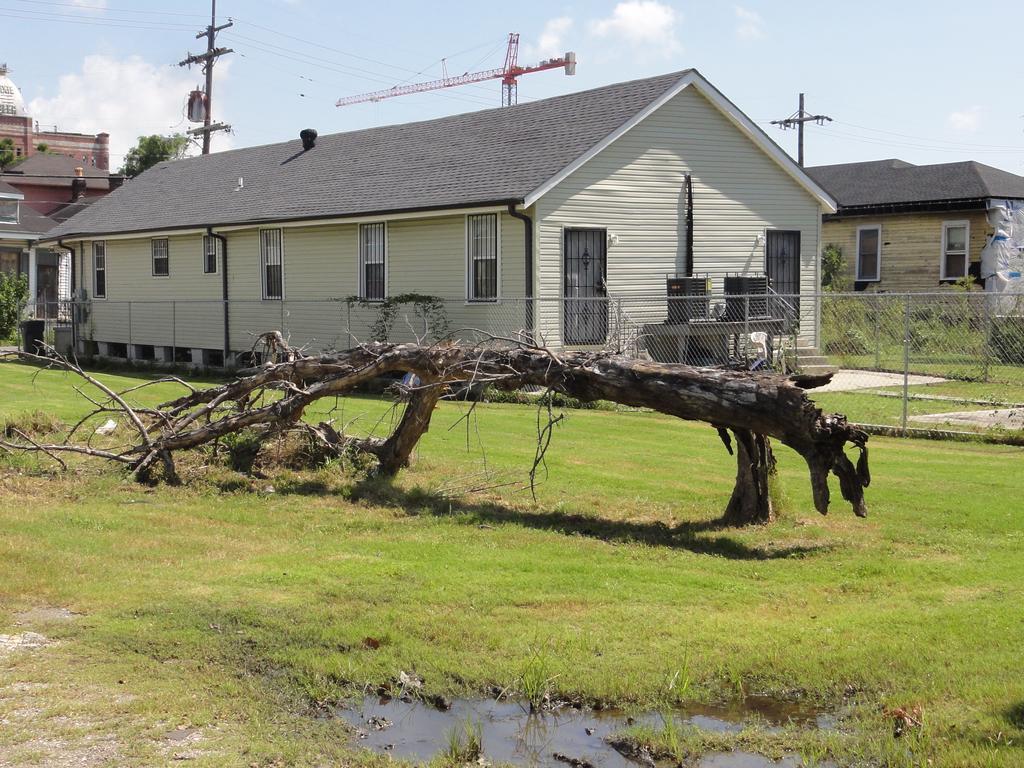Describe this image in one or two sentences. In this image in the front there is water and there's grass on the ground. In the center there is a branch of a tree. In the background there are buildings, poles, plants and there is a fence and there is a tree and the sky is cloudy. 